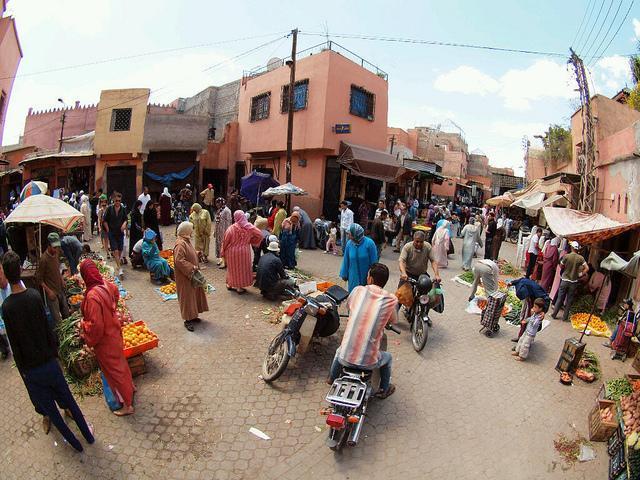How many people are there?
Give a very brief answer. 6. How many motorcycles are in the photo?
Give a very brief answer. 2. How many sandwiches are on the plate?
Give a very brief answer. 0. 